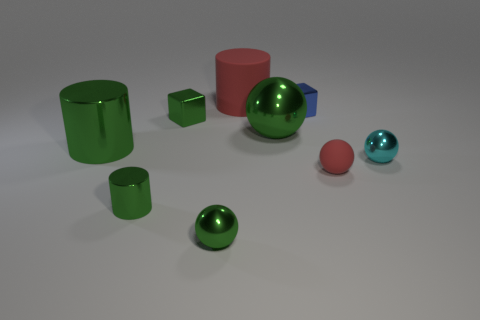Are there fewer metallic balls than green metallic balls?
Give a very brief answer. No. What number of objects are either cyan shiny cubes or tiny balls?
Keep it short and to the point. 3. Is the shape of the big red rubber thing the same as the tiny cyan object?
Provide a succinct answer. No. Is there anything else that is made of the same material as the tiny blue block?
Offer a terse response. Yes. There is a green shiny object that is to the right of the red rubber cylinder; is it the same size as the cyan metallic thing in front of the big red cylinder?
Provide a short and direct response. No. The ball that is both on the right side of the large green sphere and behind the small red matte ball is made of what material?
Your response must be concise. Metal. Are there any other things of the same color as the rubber cylinder?
Make the answer very short. Yes. Are there fewer cyan balls in front of the tiny green metal sphere than cylinders?
Provide a short and direct response. Yes. Is the number of small brown things greater than the number of tiny green spheres?
Your response must be concise. No. Is there a green cylinder behind the green thing that is on the right side of the tiny metallic ball that is to the left of the small red matte ball?
Give a very brief answer. No. 